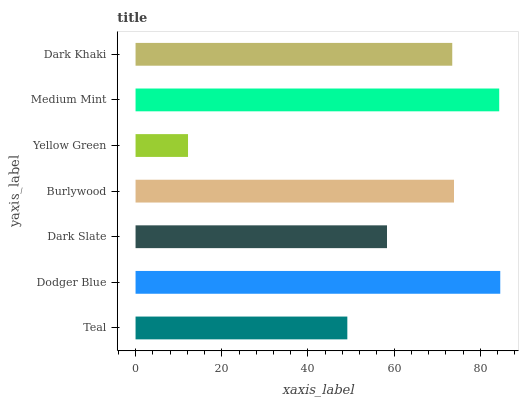Is Yellow Green the minimum?
Answer yes or no. Yes. Is Dodger Blue the maximum?
Answer yes or no. Yes. Is Dark Slate the minimum?
Answer yes or no. No. Is Dark Slate the maximum?
Answer yes or no. No. Is Dodger Blue greater than Dark Slate?
Answer yes or no. Yes. Is Dark Slate less than Dodger Blue?
Answer yes or no. Yes. Is Dark Slate greater than Dodger Blue?
Answer yes or no. No. Is Dodger Blue less than Dark Slate?
Answer yes or no. No. Is Dark Khaki the high median?
Answer yes or no. Yes. Is Dark Khaki the low median?
Answer yes or no. Yes. Is Burlywood the high median?
Answer yes or no. No. Is Teal the low median?
Answer yes or no. No. 